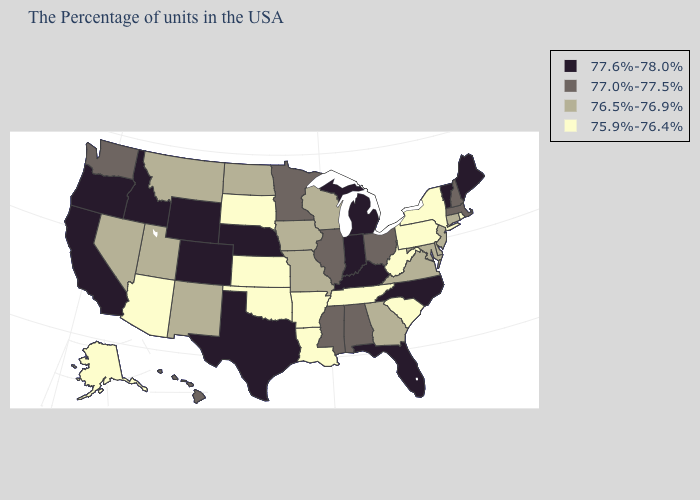Name the states that have a value in the range 76.5%-76.9%?
Give a very brief answer. Connecticut, New Jersey, Delaware, Maryland, Virginia, Georgia, Wisconsin, Missouri, Iowa, North Dakota, New Mexico, Utah, Montana, Nevada. Does the first symbol in the legend represent the smallest category?
Short answer required. No. How many symbols are there in the legend?
Write a very short answer. 4. Name the states that have a value in the range 76.5%-76.9%?
Keep it brief. Connecticut, New Jersey, Delaware, Maryland, Virginia, Georgia, Wisconsin, Missouri, Iowa, North Dakota, New Mexico, Utah, Montana, Nevada. Which states have the lowest value in the West?
Short answer required. Arizona, Alaska. Name the states that have a value in the range 76.5%-76.9%?
Write a very short answer. Connecticut, New Jersey, Delaware, Maryland, Virginia, Georgia, Wisconsin, Missouri, Iowa, North Dakota, New Mexico, Utah, Montana, Nevada. What is the value of Alaska?
Be succinct. 75.9%-76.4%. Among the states that border Ohio , does Indiana have the lowest value?
Concise answer only. No. What is the highest value in the South ?
Quick response, please. 77.6%-78.0%. What is the lowest value in the USA?
Short answer required. 75.9%-76.4%. Name the states that have a value in the range 76.5%-76.9%?
Give a very brief answer. Connecticut, New Jersey, Delaware, Maryland, Virginia, Georgia, Wisconsin, Missouri, Iowa, North Dakota, New Mexico, Utah, Montana, Nevada. Which states have the lowest value in the West?
Write a very short answer. Arizona, Alaska. Does Wyoming have the highest value in the USA?
Give a very brief answer. Yes. Which states hav the highest value in the MidWest?
Short answer required. Michigan, Indiana, Nebraska. 